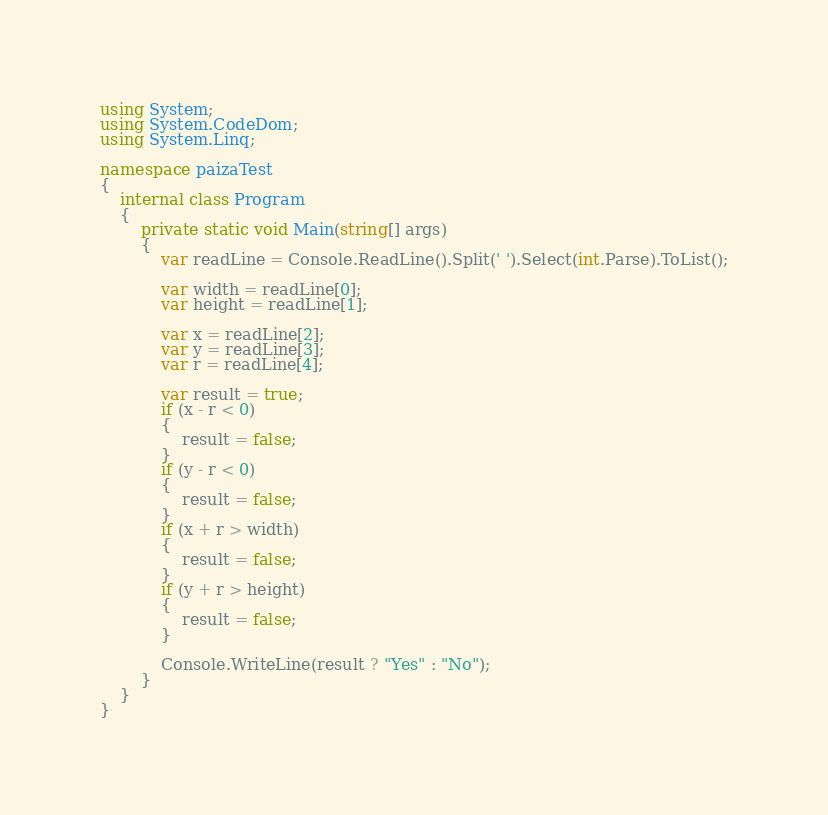<code> <loc_0><loc_0><loc_500><loc_500><_C#_>using System;
using System.CodeDom;
using System.Linq;

namespace paizaTest
{
    internal class Program
    {
        private static void Main(string[] args)
        {
            var readLine = Console.ReadLine().Split(' ').Select(int.Parse).ToList();

            var width = readLine[0];
            var height = readLine[1];

            var x = readLine[2];
            var y = readLine[3];
            var r = readLine[4];

            var result = true;
            if (x - r < 0)
            {
                result = false;
            }
            if (y - r < 0)
            {
                result = false;
            }
            if (x + r > width)
            {
                result = false;
            }
            if (y + r > height)
            {
                result = false;
            }

            Console.WriteLine(result ? "Yes" : "No");
        }
    }
}</code> 